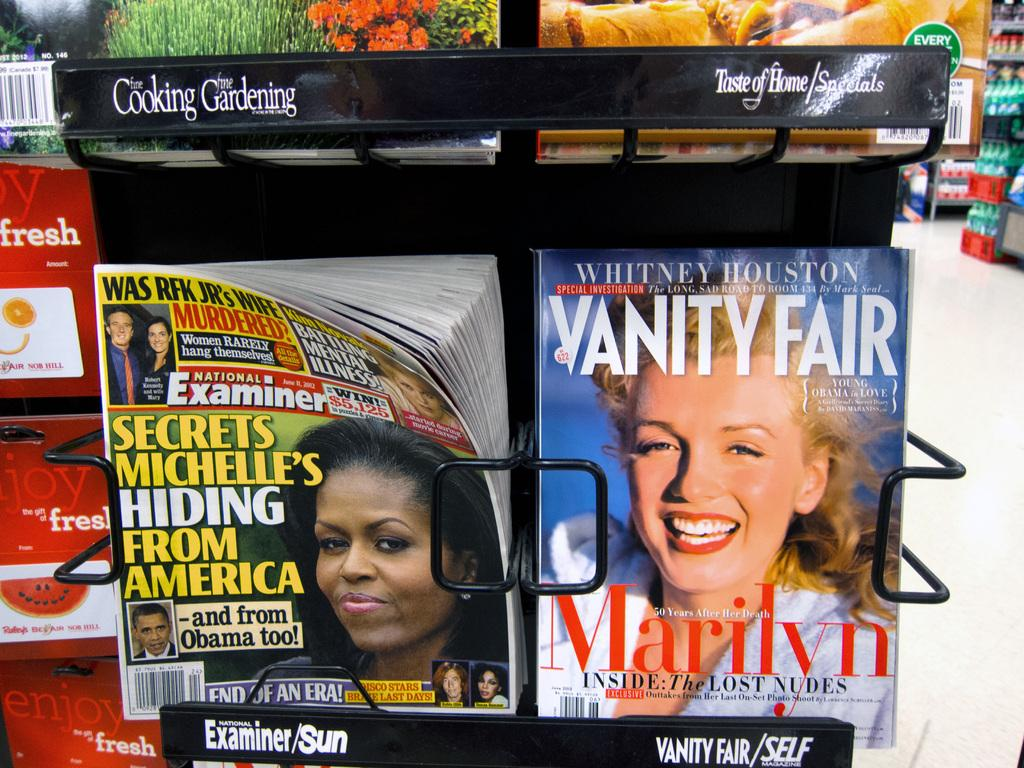What type of reading material is present in the image? There are magazines in a stand in the image. Can you describe any objects visible in the background of the image? Unfortunately, the provided facts do not give any specific details about the objects in the background. How many times did the comb get used on that particular day in the image? There is no comb present in the image, so it is not possible to determine how many times it was used on any given day. 